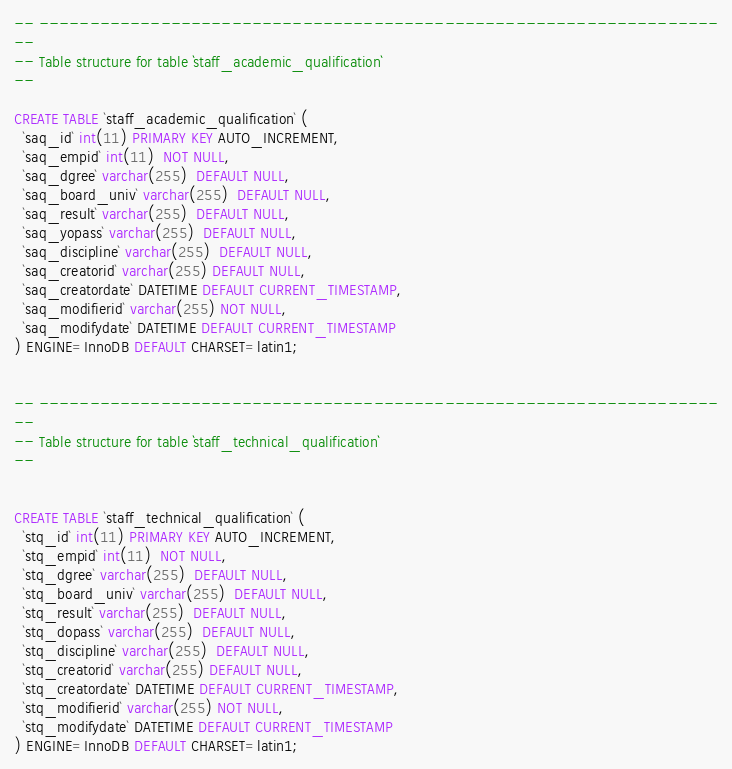<code> <loc_0><loc_0><loc_500><loc_500><_SQL_>-- -------------------------------------------------------------------
--
-- Table structure for table `staff_academic_qualification`
--

CREATE TABLE `staff_academic_qualification` (
  `saq_id` int(11) PRIMARY KEY AUTO_INCREMENT,
  `saq_empid` int(11)  NOT NULL,
  `saq_dgree` varchar(255)  DEFAULT NULL,
  `saq_board_univ` varchar(255)  DEFAULT NULL,
  `saq_result` varchar(255)  DEFAULT NULL,
  `saq_yopass` varchar(255)  DEFAULT NULL,
  `saq_discipline` varchar(255)  DEFAULT NULL,
  `saq_creatorid` varchar(255) DEFAULT NULL,
  `saq_creatordate` DATETIME DEFAULT CURRENT_TIMESTAMP,
  `saq_modifierid` varchar(255) NOT NULL,
  `saq_modifydate` DATETIME DEFAULT CURRENT_TIMESTAMP
) ENGINE=InnoDB DEFAULT CHARSET=latin1;


-- -------------------------------------------------------------------
--
-- Table structure for table `staff_technical_qualification`
--


CREATE TABLE `staff_technical_qualification` (
  `stq_id` int(11) PRIMARY KEY AUTO_INCREMENT,
  `stq_empid` int(11)  NOT NULL,
  `stq_dgree` varchar(255)  DEFAULT NULL,
  `stq_board_univ` varchar(255)  DEFAULT NULL,
  `stq_result` varchar(255)  DEFAULT NULL,
  `stq_dopass` varchar(255)  DEFAULT NULL,
  `stq_discipline` varchar(255)  DEFAULT NULL,
  `stq_creatorid` varchar(255) DEFAULT NULL,
  `stq_creatordate` DATETIME DEFAULT CURRENT_TIMESTAMP,
  `stq_modifierid` varchar(255) NOT NULL,
  `stq_modifydate` DATETIME DEFAULT CURRENT_TIMESTAMP
) ENGINE=InnoDB DEFAULT CHARSET=latin1;

</code> 